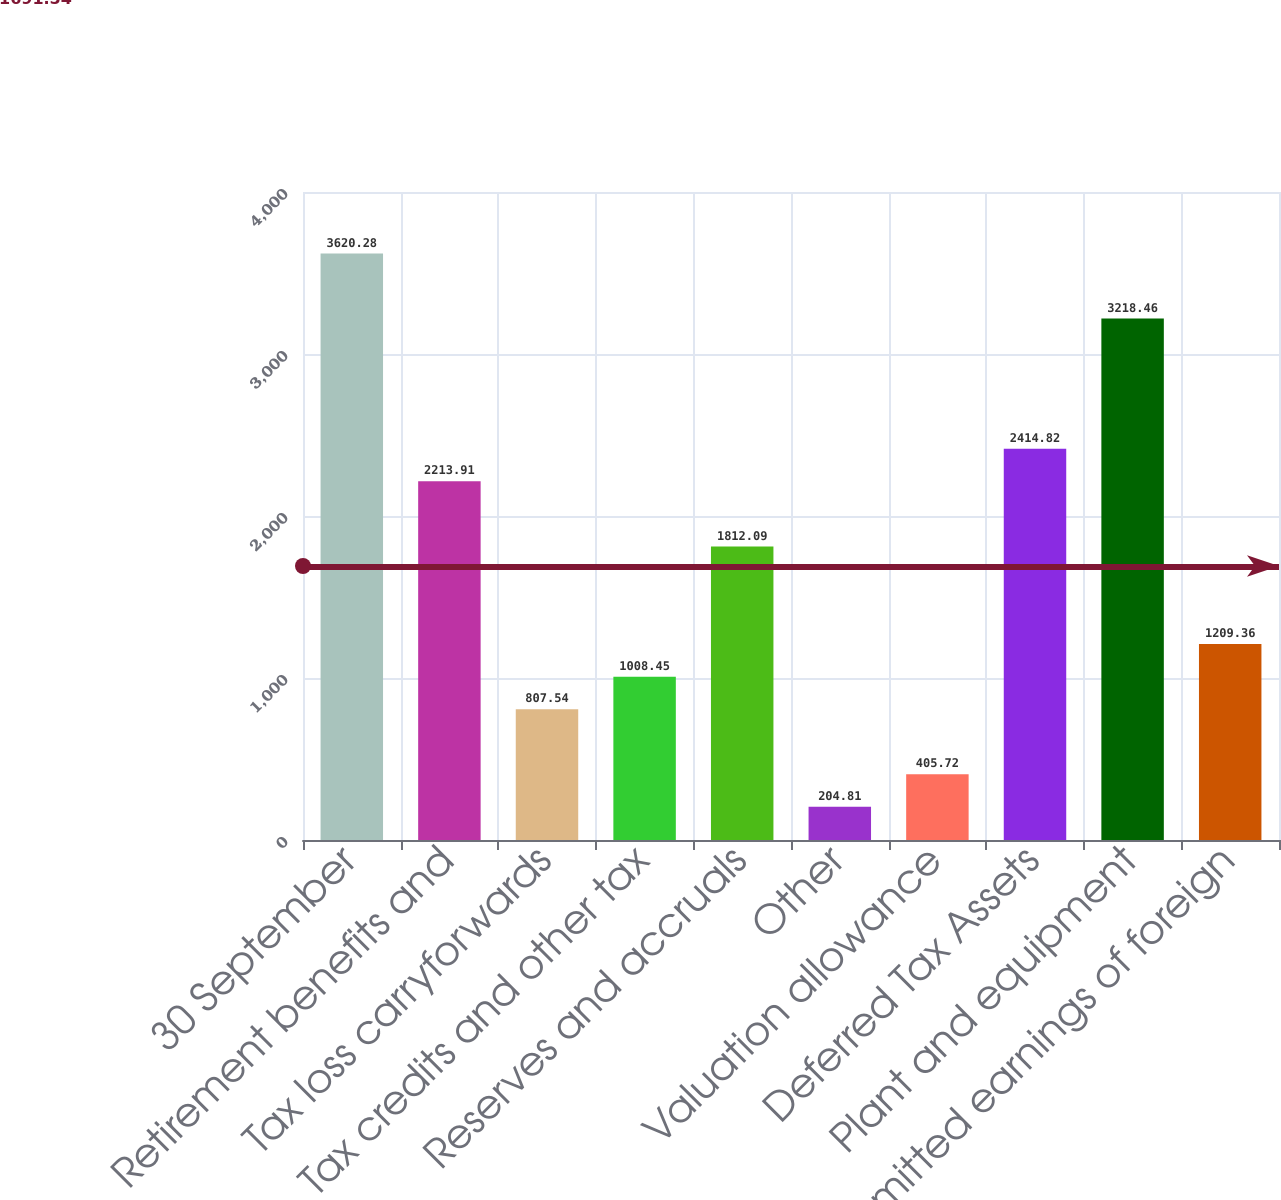Convert chart to OTSL. <chart><loc_0><loc_0><loc_500><loc_500><bar_chart><fcel>30 September<fcel>Retirement benefits and<fcel>Tax loss carryforwards<fcel>Tax credits and other tax<fcel>Reserves and accruals<fcel>Other<fcel>Valuation allowance<fcel>Deferred Tax Assets<fcel>Plant and equipment<fcel>Unremitted earnings of foreign<nl><fcel>3620.28<fcel>2213.91<fcel>807.54<fcel>1008.45<fcel>1812.09<fcel>204.81<fcel>405.72<fcel>2414.82<fcel>3218.46<fcel>1209.36<nl></chart> 